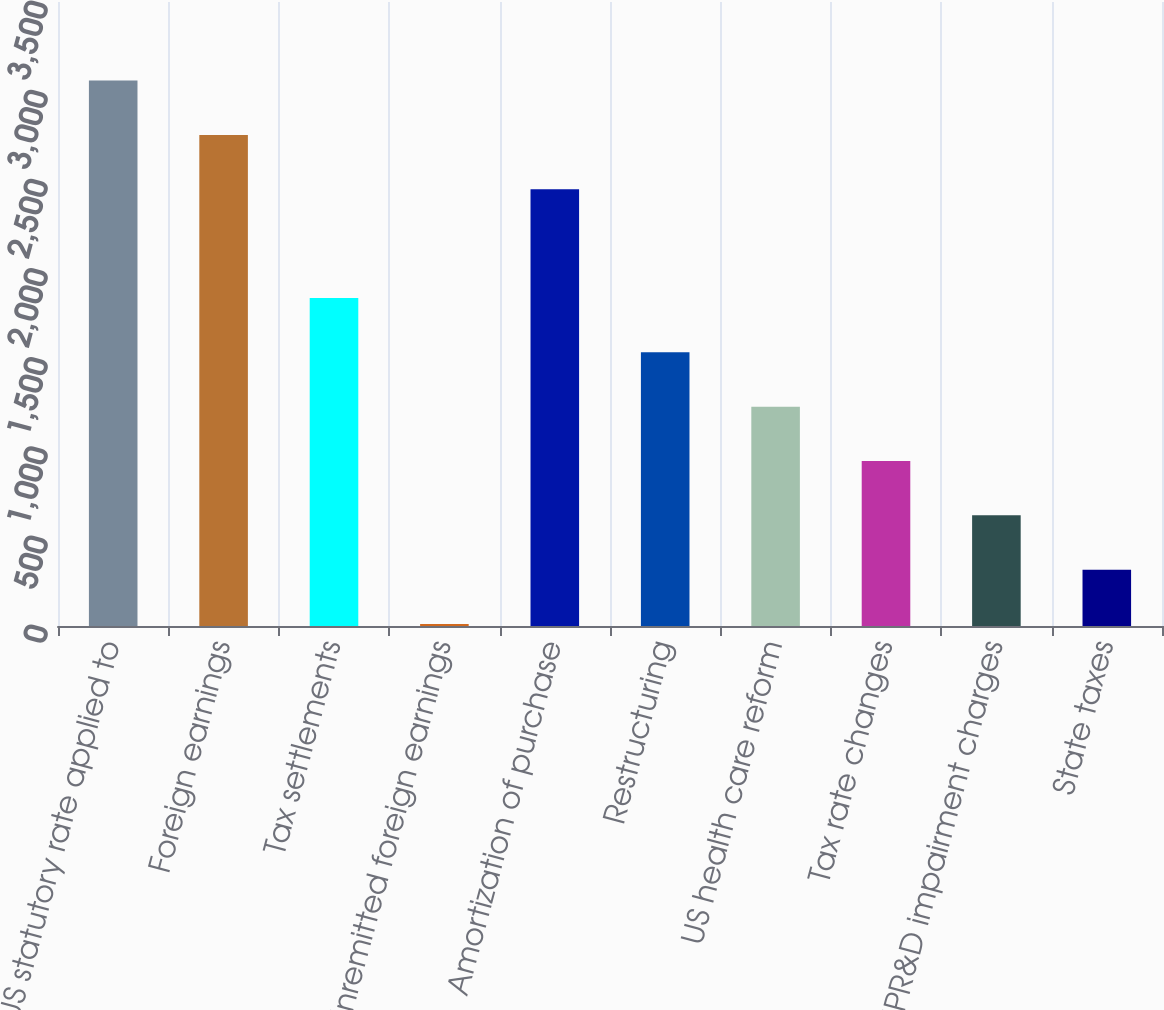<chart> <loc_0><loc_0><loc_500><loc_500><bar_chart><fcel>US statutory rate applied to<fcel>Foreign earnings<fcel>Tax settlements<fcel>Unremitted foreign earnings<fcel>Amortization of purchase<fcel>Restructuring<fcel>US health care reform<fcel>Tax rate changes<fcel>IPR&D impairment charges<fcel>State taxes<nl><fcel>3059<fcel>2754.2<fcel>1839.8<fcel>11<fcel>2449.4<fcel>1535<fcel>1230.2<fcel>925.4<fcel>620.6<fcel>315.8<nl></chart> 